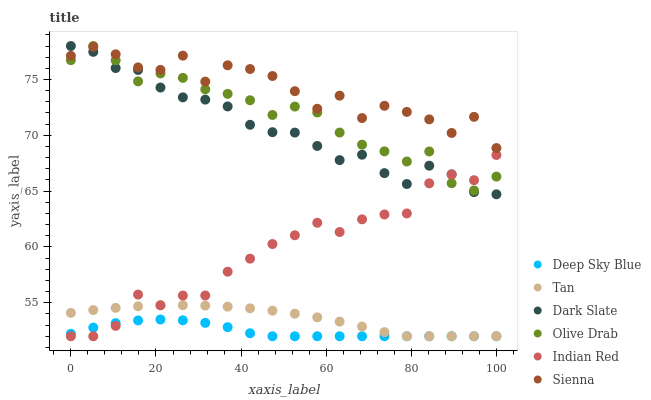Does Deep Sky Blue have the minimum area under the curve?
Answer yes or no. Yes. Does Sienna have the maximum area under the curve?
Answer yes or no. Yes. Does Dark Slate have the minimum area under the curve?
Answer yes or no. No. Does Dark Slate have the maximum area under the curve?
Answer yes or no. No. Is Tan the smoothest?
Answer yes or no. Yes. Is Sienna the roughest?
Answer yes or no. Yes. Is Dark Slate the smoothest?
Answer yes or no. No. Is Dark Slate the roughest?
Answer yes or no. No. Does Deep Sky Blue have the lowest value?
Answer yes or no. Yes. Does Dark Slate have the lowest value?
Answer yes or no. No. Does Olive Drab have the highest value?
Answer yes or no. Yes. Does Sienna have the highest value?
Answer yes or no. No. Is Deep Sky Blue less than Olive Drab?
Answer yes or no. Yes. Is Olive Drab greater than Tan?
Answer yes or no. Yes. Does Dark Slate intersect Sienna?
Answer yes or no. Yes. Is Dark Slate less than Sienna?
Answer yes or no. No. Is Dark Slate greater than Sienna?
Answer yes or no. No. Does Deep Sky Blue intersect Olive Drab?
Answer yes or no. No. 